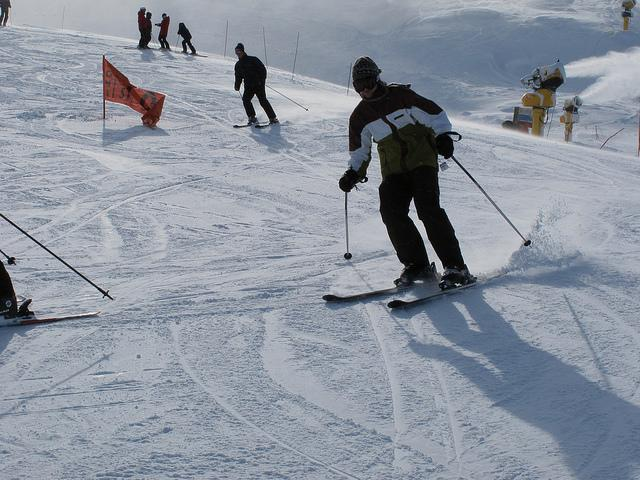What is this activity for?

Choices:
A) racing
B) photo taking
C) practice
D) leisure racing 